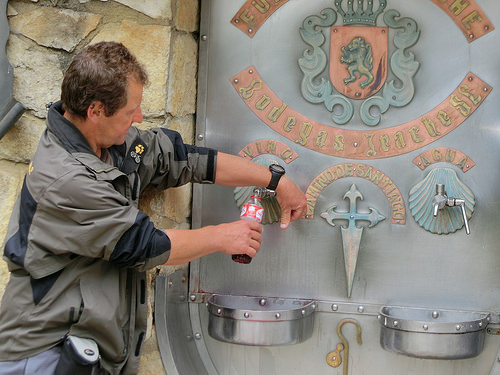<image>
Is there a wall to the left of the bottle? Yes. From this viewpoint, the wall is positioned to the left side relative to the bottle. 